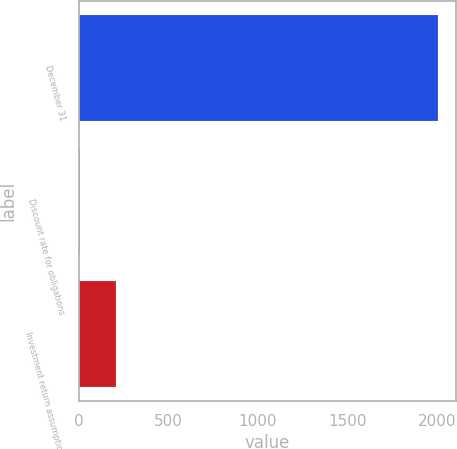<chart> <loc_0><loc_0><loc_500><loc_500><bar_chart><fcel>December 31<fcel>Discount rate for obligations<fcel>Investment return assumptions<nl><fcel>2008<fcel>6.75<fcel>206.88<nl></chart> 